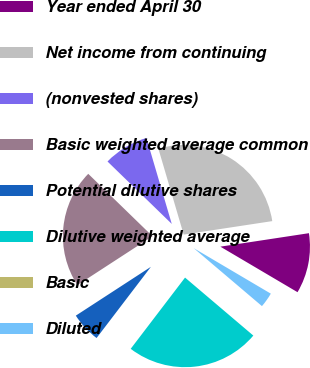<chart> <loc_0><loc_0><loc_500><loc_500><pie_chart><fcel>Year ended April 30<fcel>Net income from continuing<fcel>(nonvested shares)<fcel>Basic weighted average common<fcel>Potential dilutive shares<fcel>Dilutive weighted average<fcel>Basic<fcel>Diluted<nl><fcel>10.89%<fcel>27.16%<fcel>8.17%<fcel>21.45%<fcel>5.45%<fcel>24.17%<fcel>0.0%<fcel>2.72%<nl></chart> 